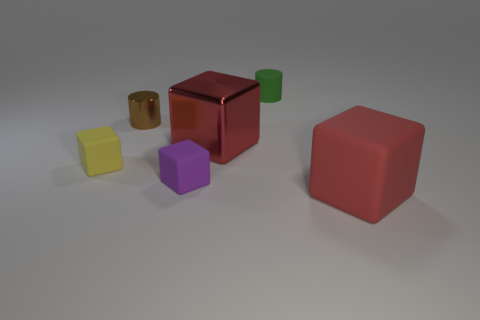Add 3 purple things. How many objects exist? 9 Subtract all matte cubes. How many cubes are left? 1 Subtract all yellow blocks. How many blocks are left? 3 Subtract 2 cylinders. How many cylinders are left? 0 Subtract all blocks. How many objects are left? 2 Subtract 0 cyan cubes. How many objects are left? 6 Subtract all yellow cylinders. Subtract all purple blocks. How many cylinders are left? 2 Subtract all red cylinders. How many red blocks are left? 2 Subtract all large gray metallic cylinders. Subtract all tiny green things. How many objects are left? 5 Add 4 blocks. How many blocks are left? 8 